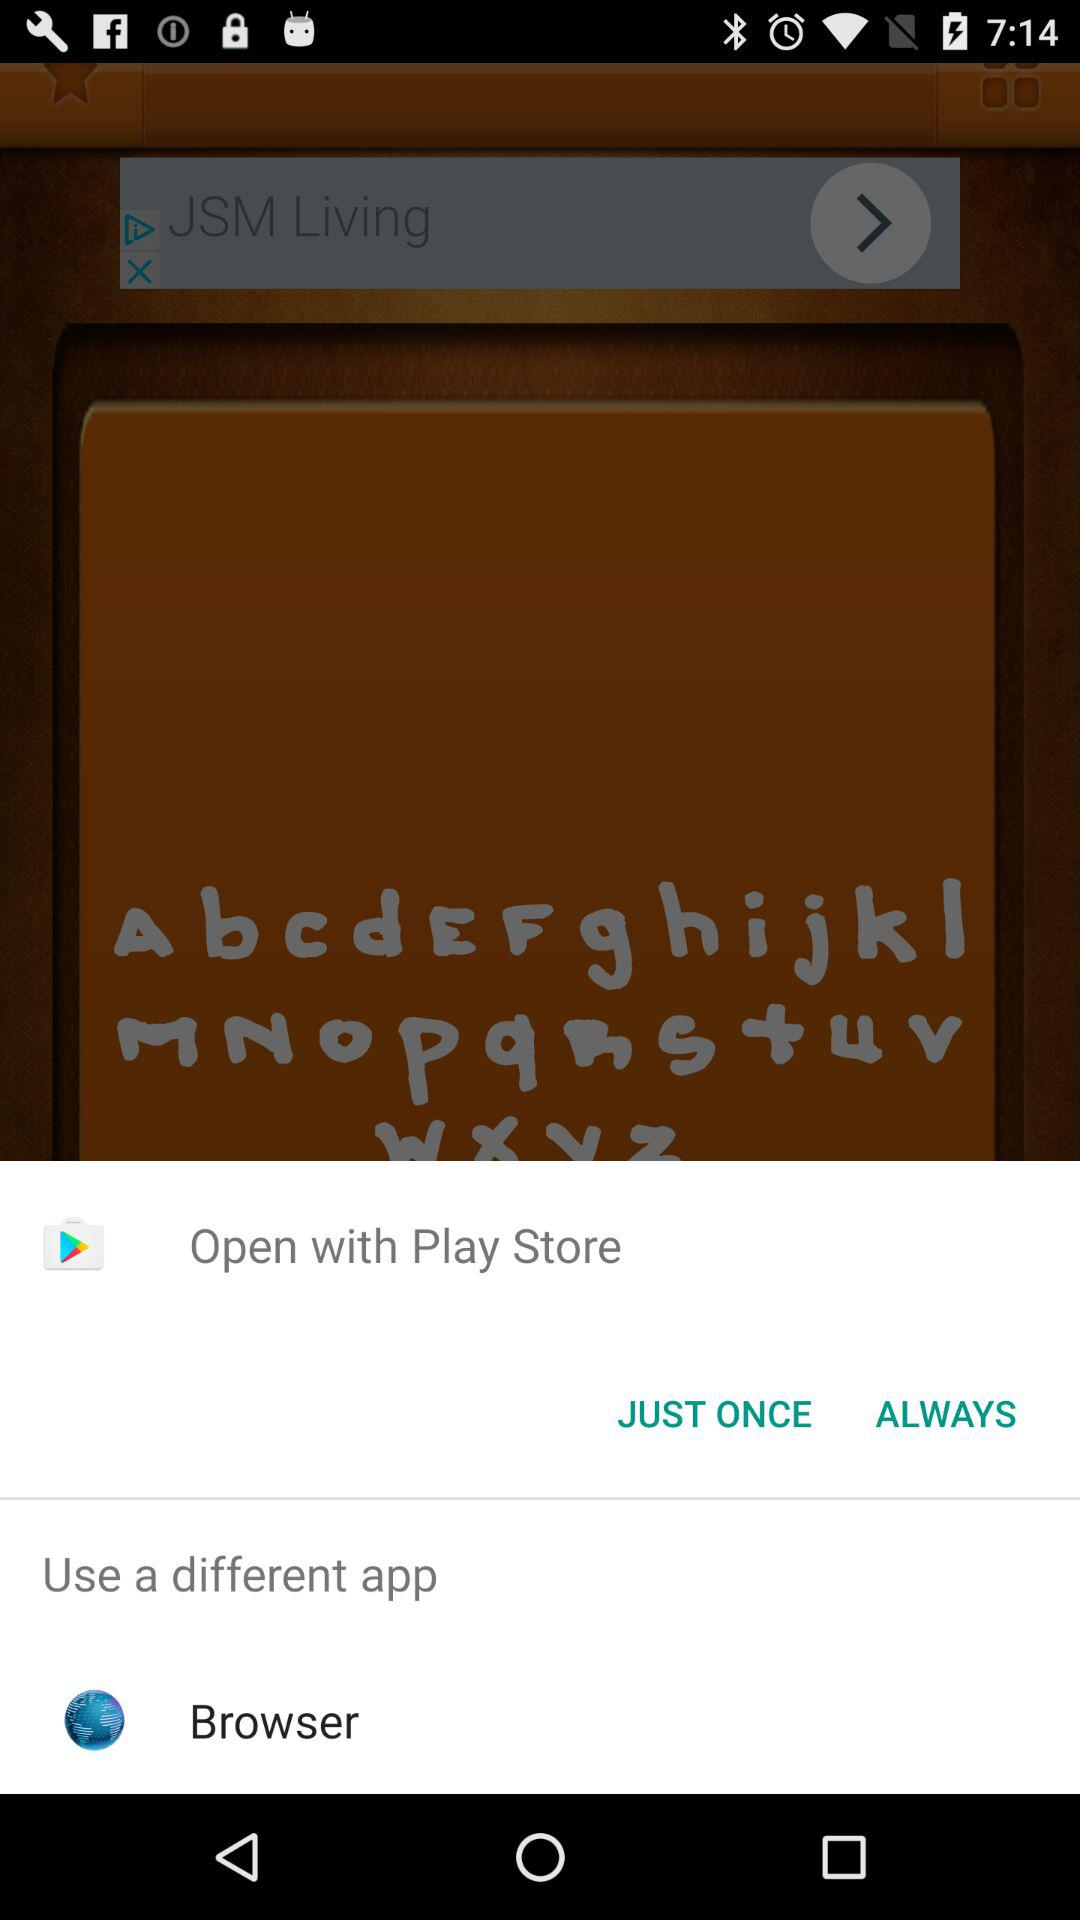By which application can the commanded action be done? The commanded action can be done by "Play Store" and "Browser". 